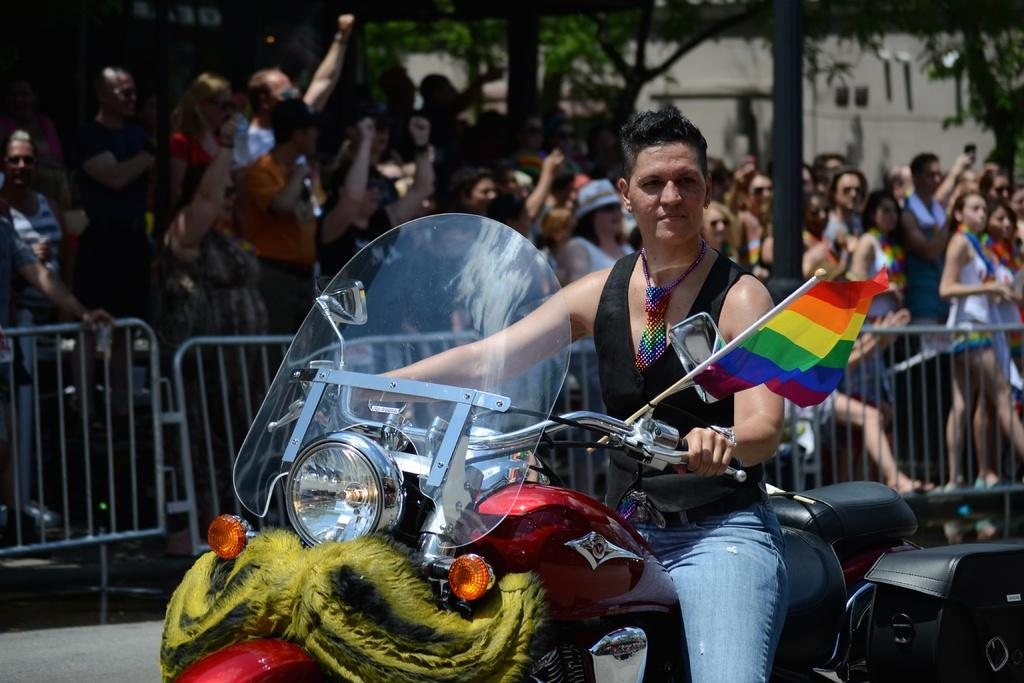How many people are in the image? There is a group of people in the image. What is one person in the group doing? One person is riding a motorcycle. What accessory is the person riding the motorcycle wearing? The person riding the motorcycle is wearing a watch. What can be seen in the background of the image? There is a house and trees in the background of the image. How many apples are being held by the giants in the image? There are no giants or apples present in the image. Why are the people in the image crying? There is no indication in the image that the people are crying. 